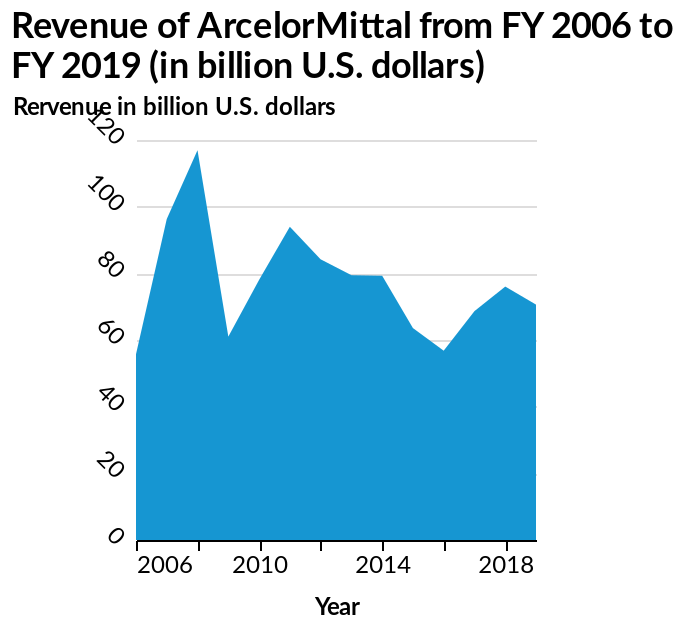<image>
How much revenue did ArcelorMittal nearly hit after 2008?  ArcelorMittal nearly hit 120 billion dollars in revenue after 2008. When did ArcelorMittal's revenue reach its highest?  ArcelorMittal's revenue reached its highest just after 2008. What is the highest revenue reached by ArcelorMittal?  The highest revenue reached by ArcelorMittal was nearly 120 billion dollars. 